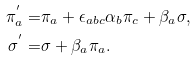<formula> <loc_0><loc_0><loc_500><loc_500>\pi ^ { ^ { \prime } } _ { a } = & \pi _ { a } + \epsilon _ { a b c } \alpha _ { b } \pi _ { c } + \beta _ { a } \sigma , \\ \sigma ^ { ^ { \prime } } = & \sigma + \beta _ { a } \pi _ { a } .</formula> 